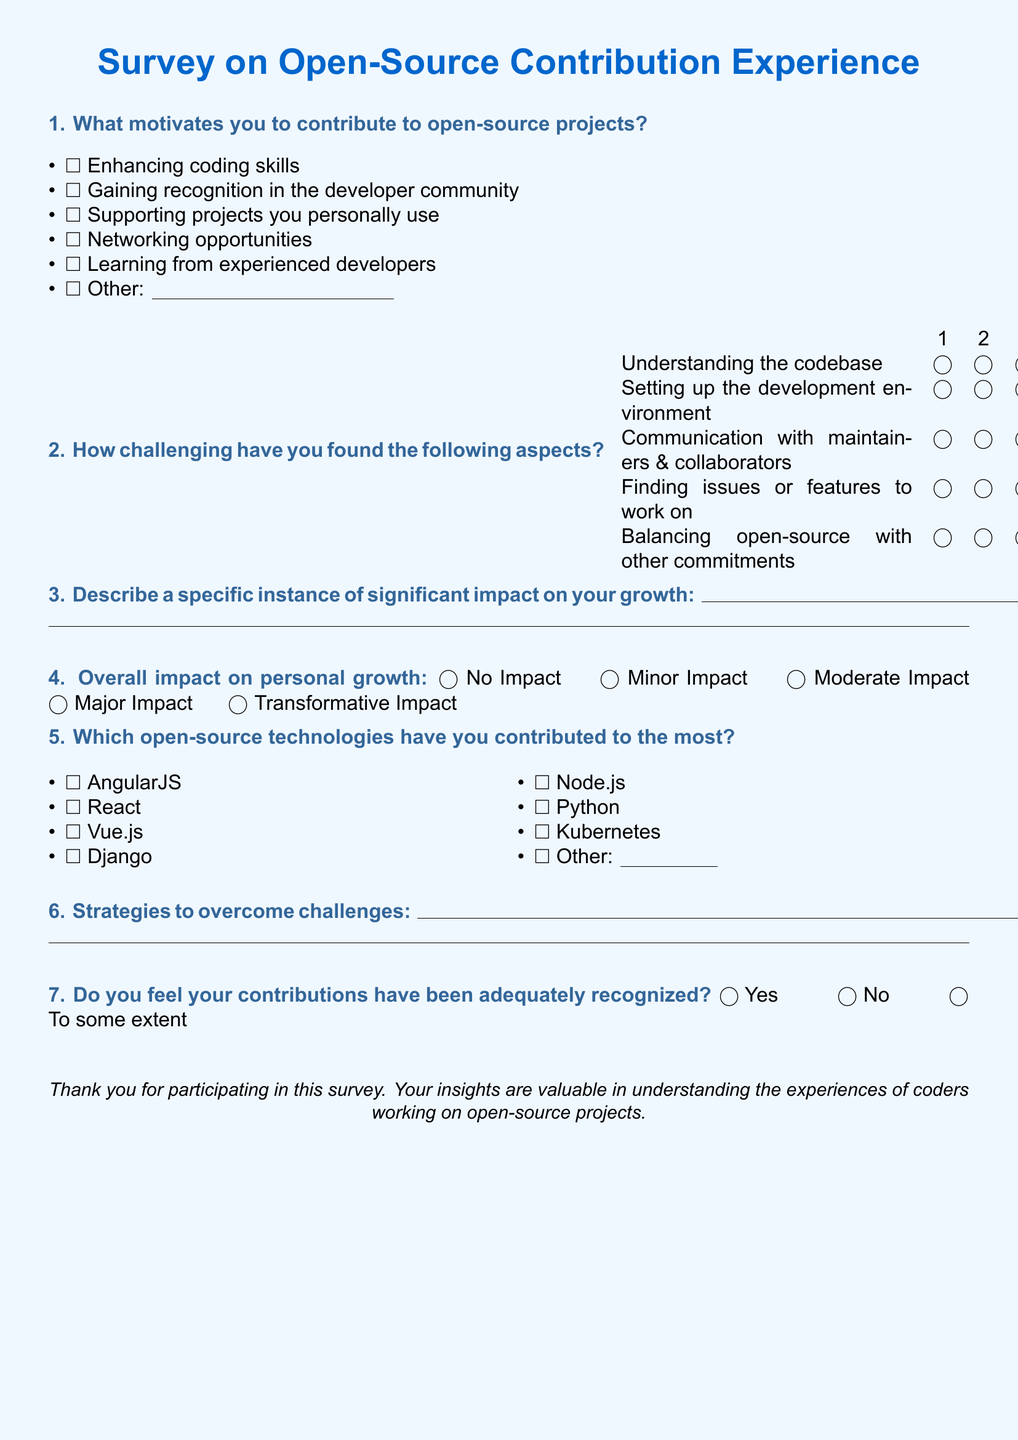What is the main title of the survey? The title is found at the beginning of the document, indicating the focus of the survey.
Answer: Survey on Open-Source Contribution Experience What is one of the motivations to contribute to open-source projects? This can be found in the list of motivations provided in the document.
Answer: Enhancing coding skills How many challenges are listed in the survey? The document includes various aspects that respondents have found challenging, which can be counted.
Answer: Five What is the lowest rating option for challenges? The rating scale provided for challenges includes several options; the lowest can be identified.
Answer: One Which open-source technology is mentioned first in the list of contributions? The order of technologies listed gives the first one contributing to open-source projects.
Answer: AngularJS How is the overall impact on personal growth assessed? The document outlines the various levels of impact that can be selected, which represent a range of effects.
Answer: No Impact What should participants do if they have a strategy to overcome challenges? The document provides space for respondents to describe their strategies in a specific section.
Answer: Write it down Do respondents feel their contributions have been recognized? The document includes a direct question about recognition for contributions that can be answered simply.
Answer: Yes 